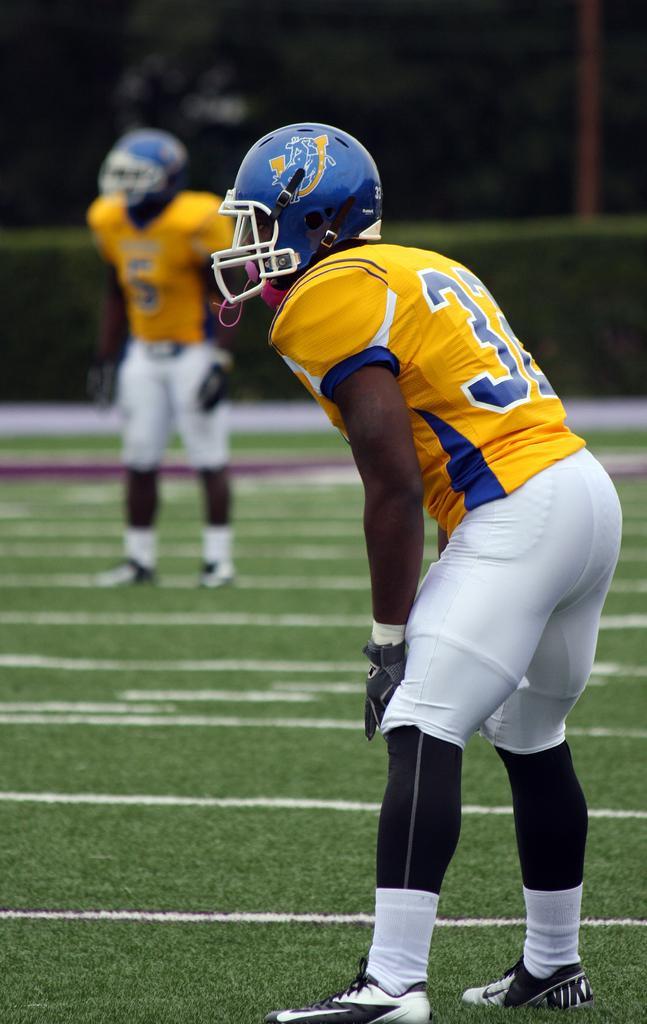Can you describe this image briefly? In this image I can see an open grass ground and on it I can see two persons are standing. I can also see both of them are wearing same colour of dress, blue colour helmets and shoes. In the background I can see bushes, a pole and few trees. I can also see number of white lines on the ground and I can see this image is little bit blurry. 